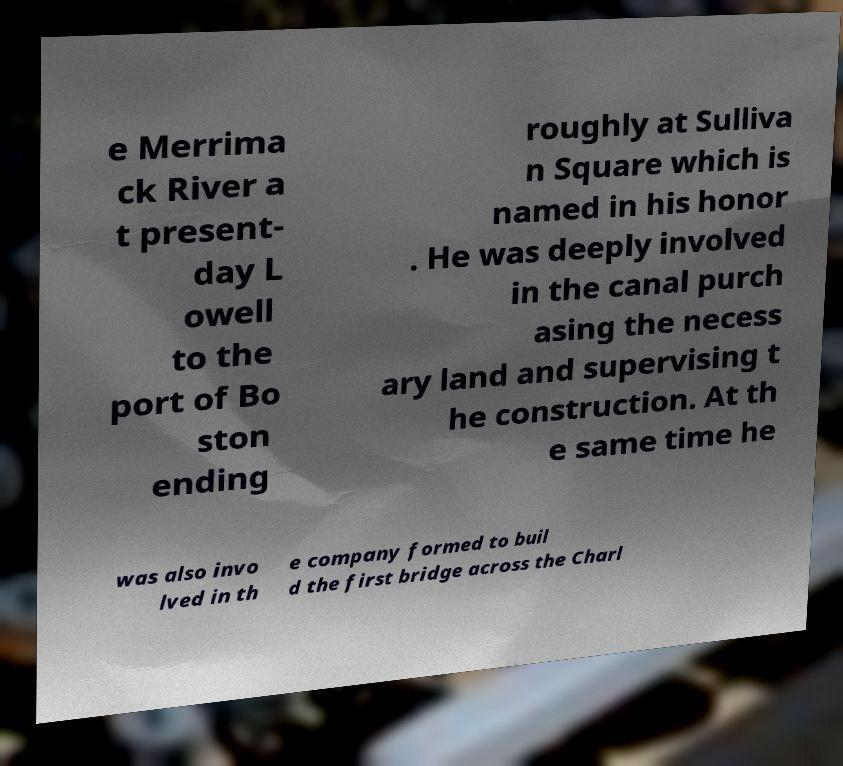Please read and relay the text visible in this image. What does it say? e Merrima ck River a t present- day L owell to the port of Bo ston ending roughly at Sulliva n Square which is named in his honor . He was deeply involved in the canal purch asing the necess ary land and supervising t he construction. At th e same time he was also invo lved in th e company formed to buil d the first bridge across the Charl 